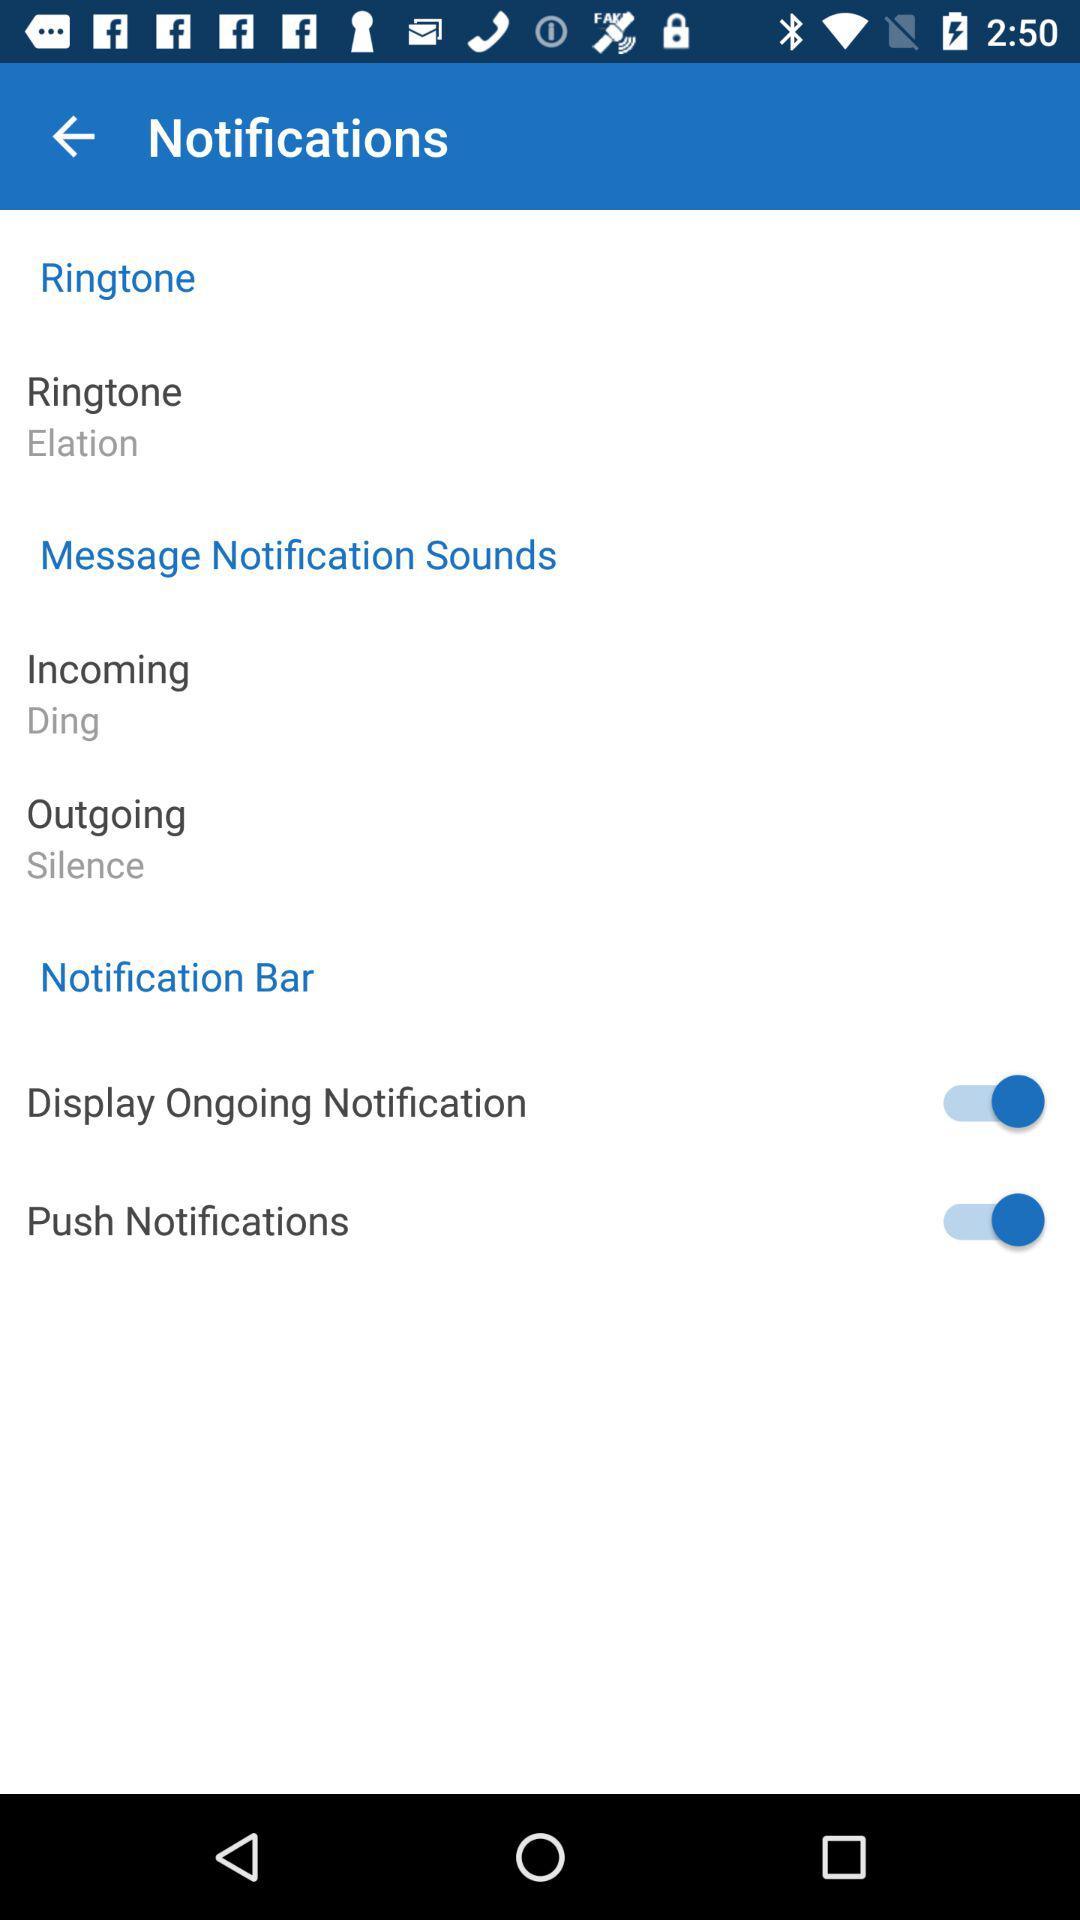What is the notification sound for an incoming message? The notification sound for an incoming message is "Ding". 